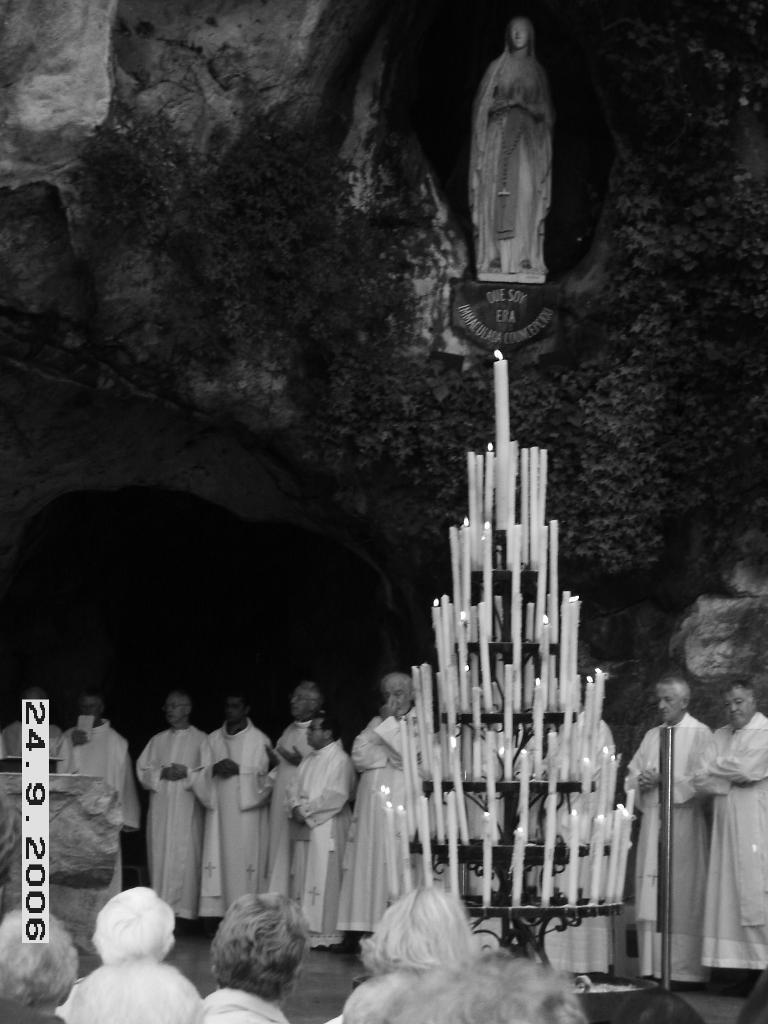What is happening with the group of people in the image? The group of people is standing in the image. What objects are in front of the group of people? There are candles in front of the group of people. What can be seen in the background of the image? There is a statue in the background of the image. What is the color scheme of the image? The image is in black and white. Where is the locket placed in the image? There is no locket present in the image. What type of shelf can be seen in the background of the image? There is no shelf visible in the image; only a statue is present in the background. 